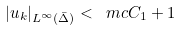<formula> <loc_0><loc_0><loc_500><loc_500>| u _ { k } | _ { L ^ { \infty } ( \bar { \Delta } ) } < \ m c C _ { 1 } + 1</formula> 